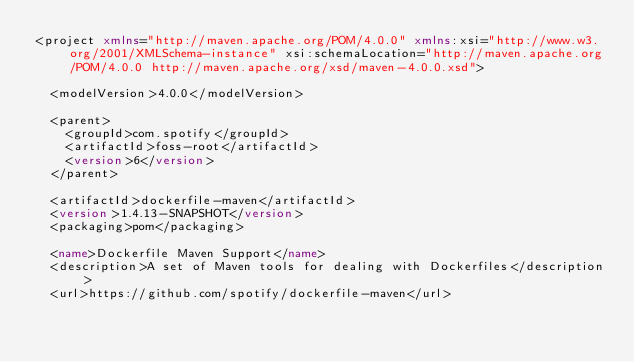Convert code to text. <code><loc_0><loc_0><loc_500><loc_500><_XML_><project xmlns="http://maven.apache.org/POM/4.0.0" xmlns:xsi="http://www.w3.org/2001/XMLSchema-instance" xsi:schemaLocation="http://maven.apache.org/POM/4.0.0 http://maven.apache.org/xsd/maven-4.0.0.xsd">

  <modelVersion>4.0.0</modelVersion>

  <parent>
    <groupId>com.spotify</groupId>
    <artifactId>foss-root</artifactId>
    <version>6</version>
  </parent>

  <artifactId>dockerfile-maven</artifactId>
  <version>1.4.13-SNAPSHOT</version>
  <packaging>pom</packaging>

  <name>Dockerfile Maven Support</name>
  <description>A set of Maven tools for dealing with Dockerfiles</description>
  <url>https://github.com/spotify/dockerfile-maven</url>
</code> 